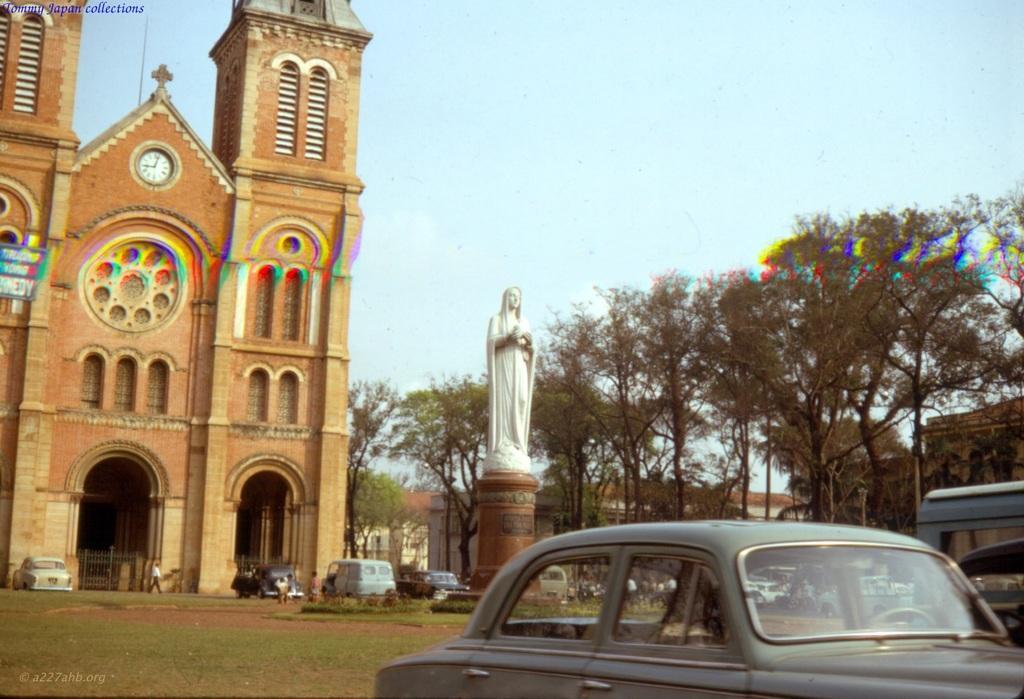In one or two sentences, can you explain what this image depicts? In this image, there are buildings, trees and a church. In front of the church, I can see few people, vehicles and a statue on a pedestal. In the background there is the sky. In the top left corner and in the bottom left corner of the image, there are watermarks. On the left side of the image, I can see a board. 